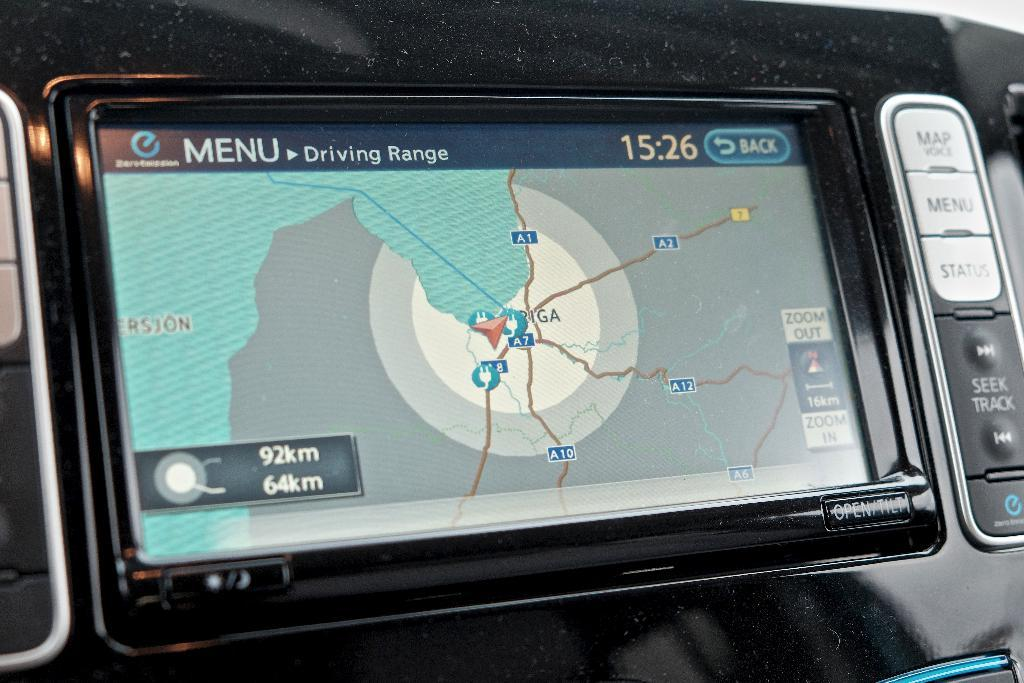What is the main subject of the image? The main subject of the image is an automotive navigation system. Are there any specific features on the navigation system? Yes, there are buttons on the right side of the image. What type of coil can be seen in the image? There is no coil present in the image; it features an automotive navigation system with buttons. How does the addition function on the navigation system work? The image does not show any addition function or provide information on how it works. 